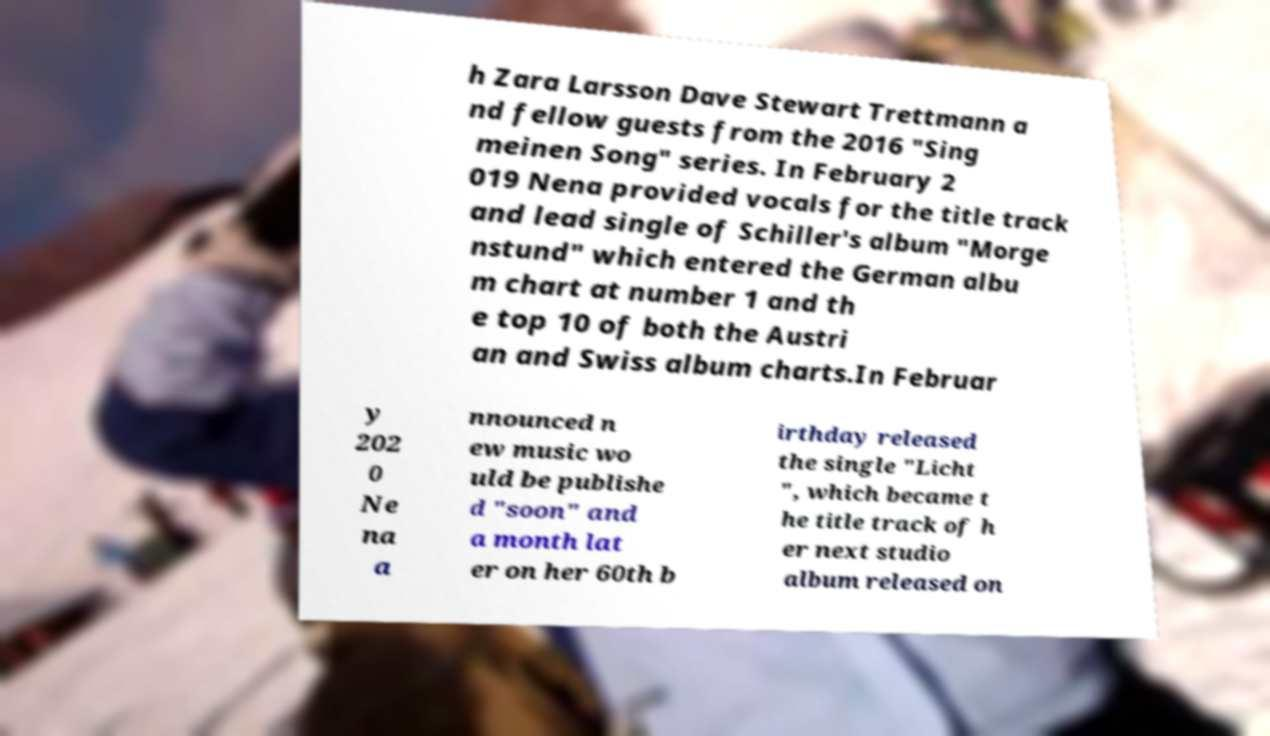Could you extract and type out the text from this image? h Zara Larsson Dave Stewart Trettmann a nd fellow guests from the 2016 "Sing meinen Song" series. In February 2 019 Nena provided vocals for the title track and lead single of Schiller's album "Morge nstund" which entered the German albu m chart at number 1 and th e top 10 of both the Austri an and Swiss album charts.In Februar y 202 0 Ne na a nnounced n ew music wo uld be publishe d "soon" and a month lat er on her 60th b irthday released the single "Licht ", which became t he title track of h er next studio album released on 